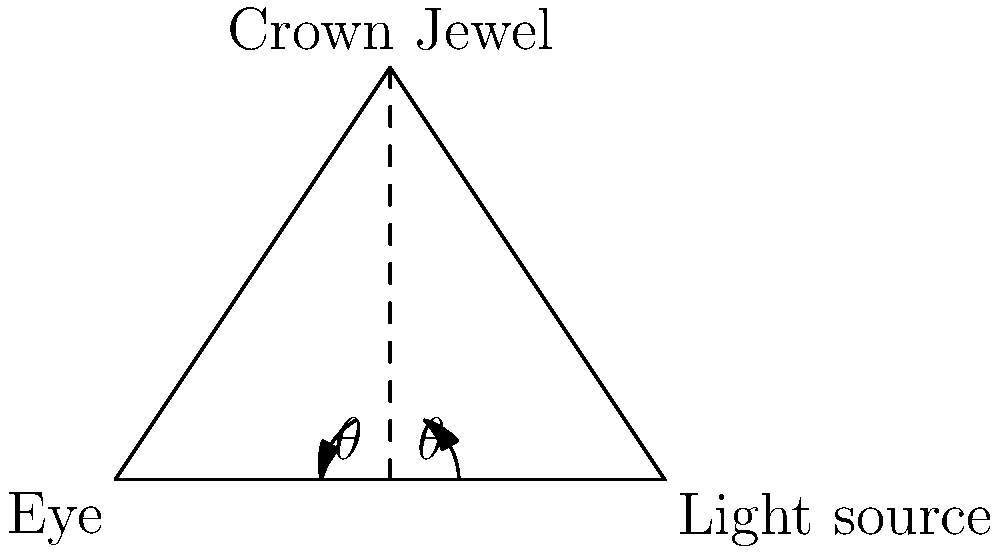During a royal ceremony, a light beam from a chandelier strikes one of the Crown Jewels at point C, creating an angle of incidence of 60°. If the reflected light reaches the eye of a loyal spectator at point A, what is the total distance traveled by the light from the source at point B to the spectator's eye? Let's approach this step-by-step:

1) First, recall the law of reflection: the angle of incidence equals the angle of reflection. In this case, both angles are 60°.

2) The triangle formed is isosceles, with BC = AC, as they form equal angles with the perpendicular bisector.

3) We can split the triangle into two right-angled triangles. Let's focus on one of them:

   $\tan 60° = \frac{height}{base/2}$

4) We know that $\tan 60° = \sqrt{3}$, so:

   $\sqrt{3} = \frac{height}{2}$
   $height = 2\sqrt{3}$

5) Now we can use the Pythagorean theorem to find the length of AC (or BC):

   $AC^2 = 2^2 + (2\sqrt{3})^2 = 4 + 12 = 16$
   $AC = 4$

6) The total distance traveled by the light is BC + AC = 4 + 4 = 8

Therefore, the total distance traveled by the light is 8 units.
Answer: 8 units 